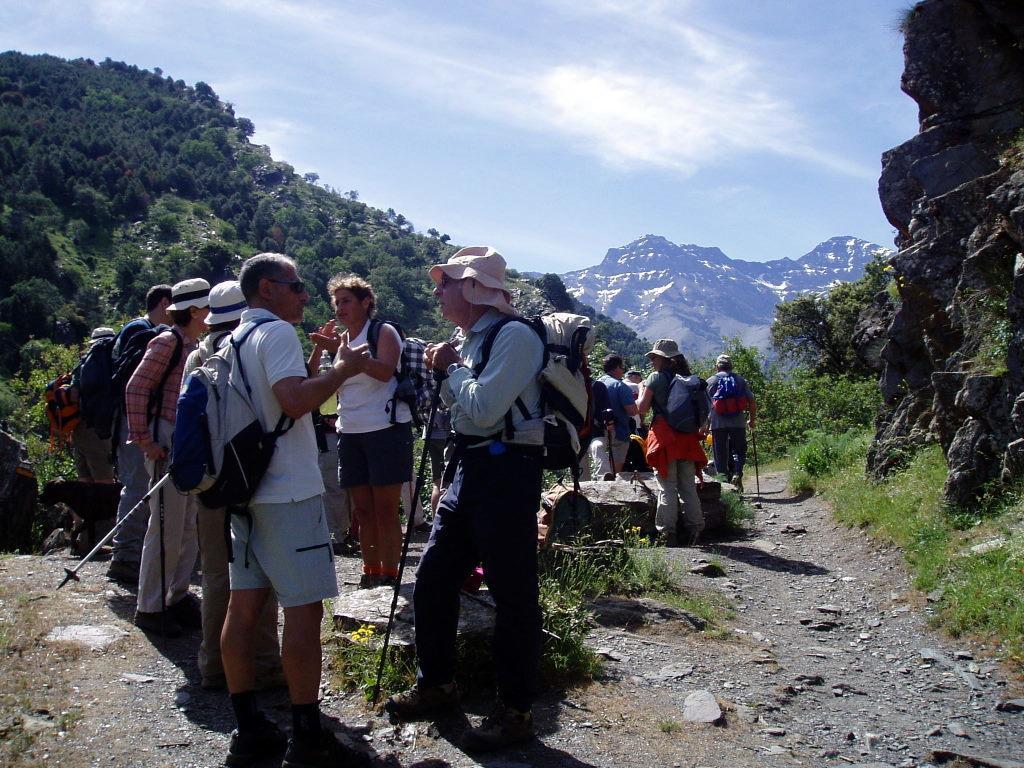How would you summarize this image in a sentence or two? There is a group of people standing as we can see trees and mountains in the background. The sky is at the top of this image. 